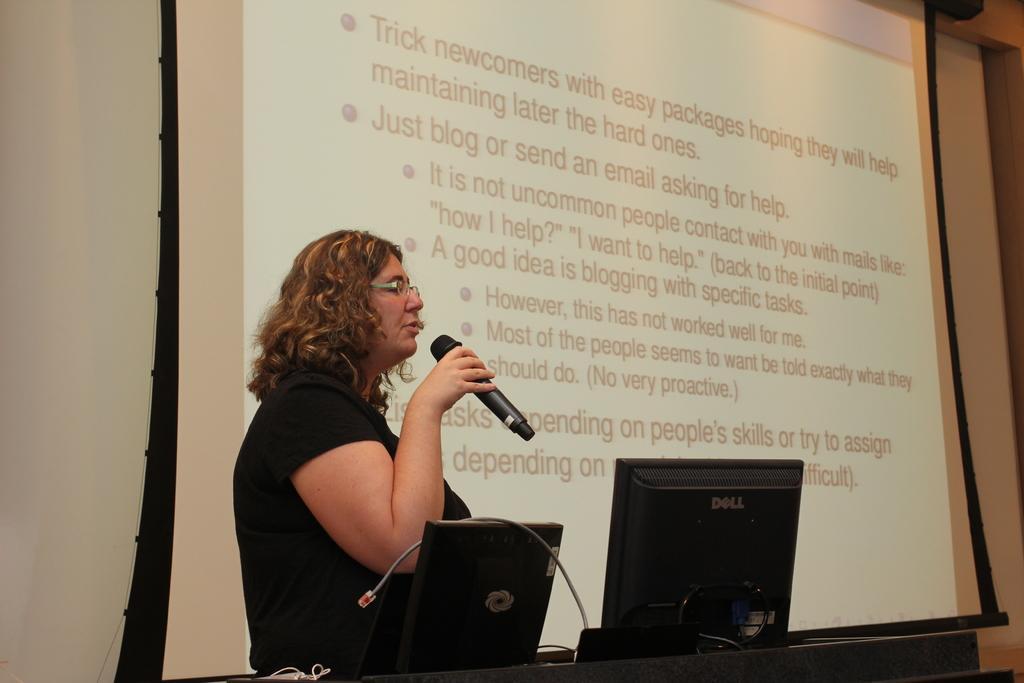Describe this image in one or two sentences. In this image I can see the person standing in-front of the podium and holding the mic. On the podium I can see the monitor and the laptop. In the background I can see the screen and the wall. 